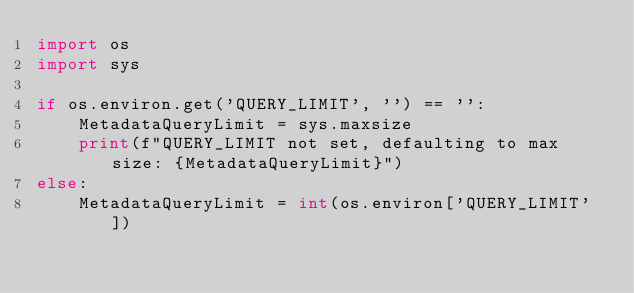<code> <loc_0><loc_0><loc_500><loc_500><_Python_>import os
import sys

if os.environ.get('QUERY_LIMIT', '') == '':
    MetadataQueryLimit = sys.maxsize
    print(f"QUERY_LIMIT not set, defaulting to max size: {MetadataQueryLimit}")
else:
    MetadataQueryLimit = int(os.environ['QUERY_LIMIT'])
</code> 